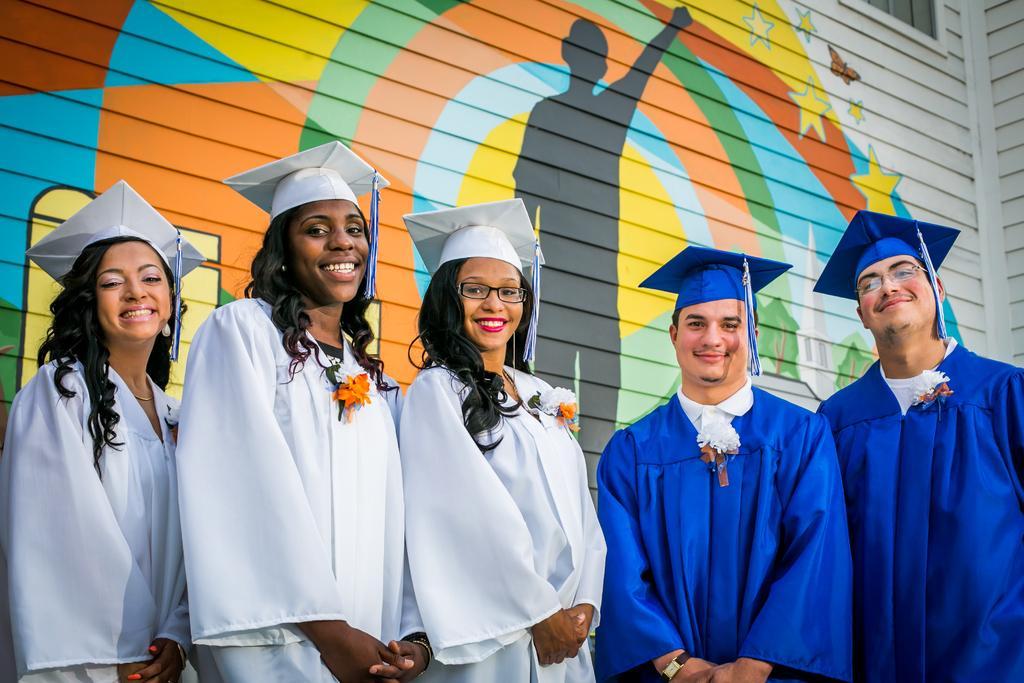Describe this image in one or two sentences. In this picture, we can see a few people in graduation suit, and hats, we can see the wall with some art. 